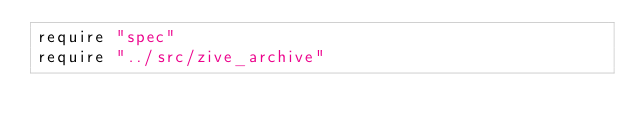<code> <loc_0><loc_0><loc_500><loc_500><_Crystal_>require "spec"
require "../src/zive_archive"
</code> 